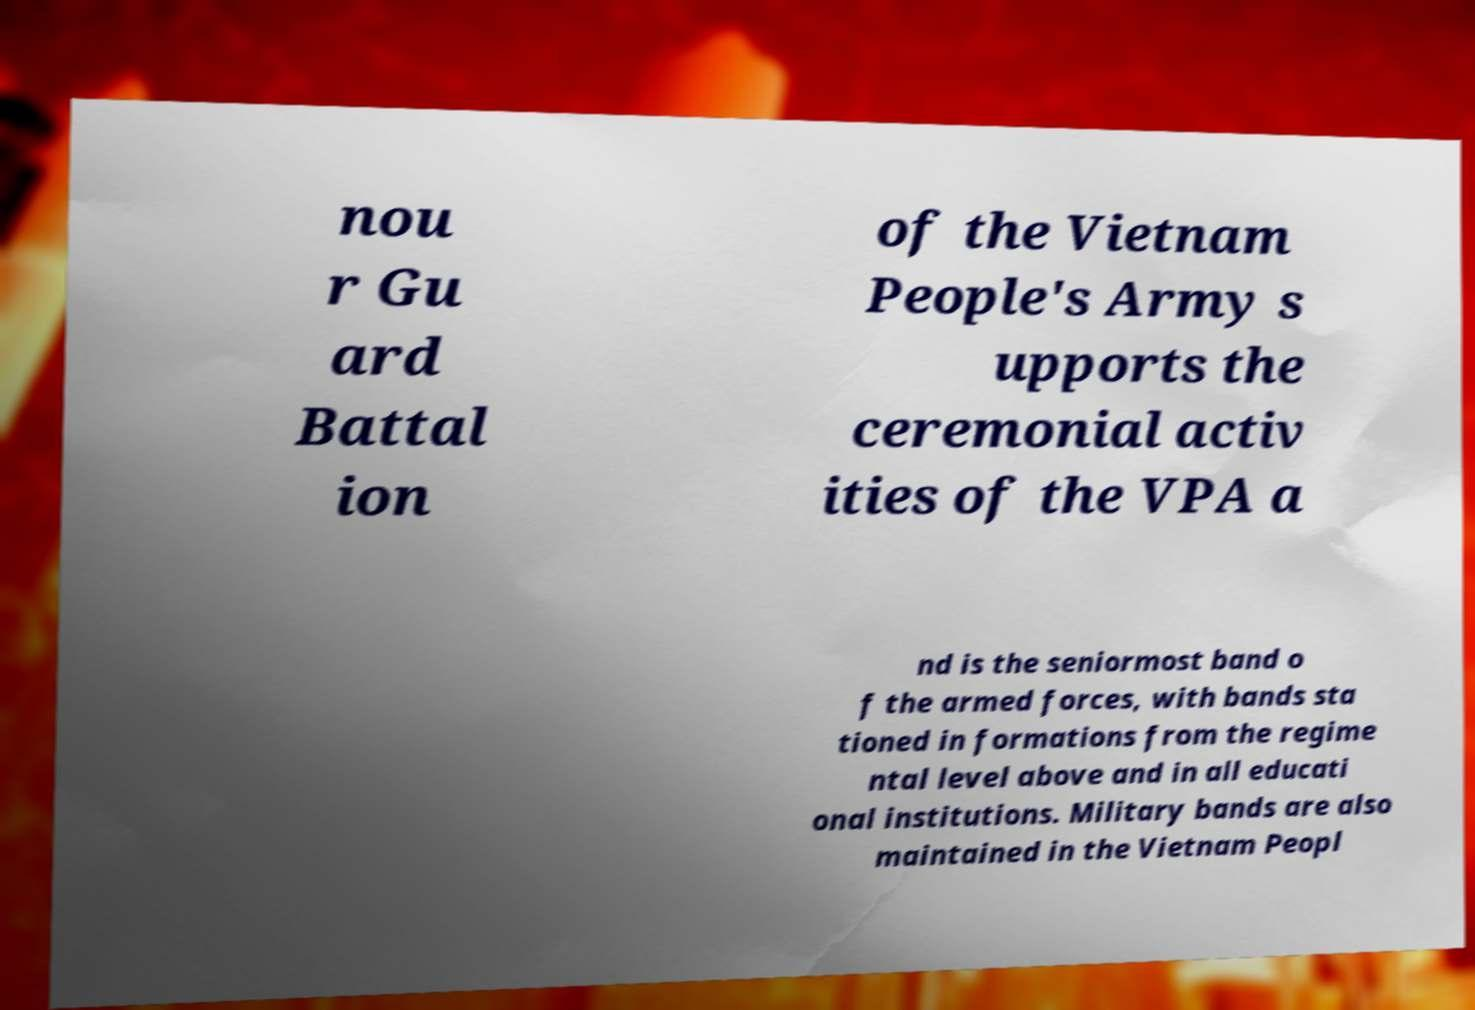Can you read and provide the text displayed in the image?This photo seems to have some interesting text. Can you extract and type it out for me? nou r Gu ard Battal ion of the Vietnam People's Army s upports the ceremonial activ ities of the VPA a nd is the seniormost band o f the armed forces, with bands sta tioned in formations from the regime ntal level above and in all educati onal institutions. Military bands are also maintained in the Vietnam Peopl 